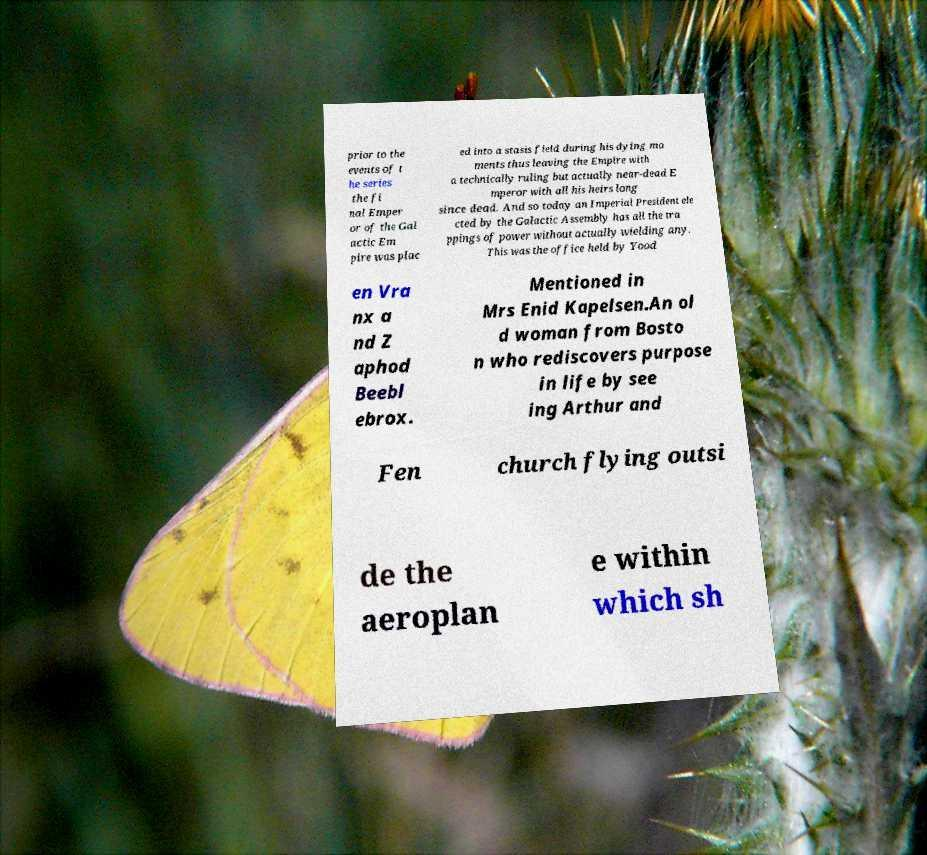Can you read and provide the text displayed in the image?This photo seems to have some interesting text. Can you extract and type it out for me? prior to the events of t he series the fi nal Emper or of the Gal actic Em pire was plac ed into a stasis field during his dying mo ments thus leaving the Empire with a technically ruling but actually near-dead E mperor with all his heirs long since dead. And so today an Imperial President ele cted by the Galactic Assembly has all the tra ppings of power without actually wielding any. This was the office held by Yood en Vra nx a nd Z aphod Beebl ebrox. Mentioned in Mrs Enid Kapelsen.An ol d woman from Bosto n who rediscovers purpose in life by see ing Arthur and Fen church flying outsi de the aeroplan e within which sh 